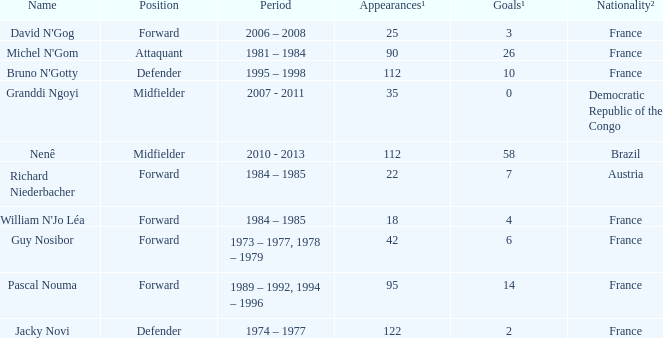How many players are from the country of Brazil? 1.0. Would you mind parsing the complete table? {'header': ['Name', 'Position', 'Period', 'Appearances¹', 'Goals¹', 'Nationality²'], 'rows': [["David N'Gog", 'Forward', '2006 – 2008', '25', '3', 'France'], ["Michel N'Gom", 'Attaquant', '1981 – 1984', '90', '26', 'France'], ["Bruno N'Gotty", 'Defender', '1995 – 1998', '112', '10', 'France'], ['Granddi Ngoyi', 'Midfielder', '2007 - 2011', '35', '0', 'Democratic Republic of the Congo'], ['Nenê', 'Midfielder', '2010 - 2013', '112', '58', 'Brazil'], ['Richard Niederbacher', 'Forward', '1984 – 1985', '22', '7', 'Austria'], ["William N'Jo Léa", 'Forward', '1984 – 1985', '18', '4', 'France'], ['Guy Nosibor', 'Forward', '1973 – 1977, 1978 – 1979', '42', '6', 'France'], ['Pascal Nouma', 'Forward', '1989 – 1992, 1994 – 1996', '95', '14', 'France'], ['Jacky Novi', 'Defender', '1974 – 1977', '122', '2', 'France']]} 